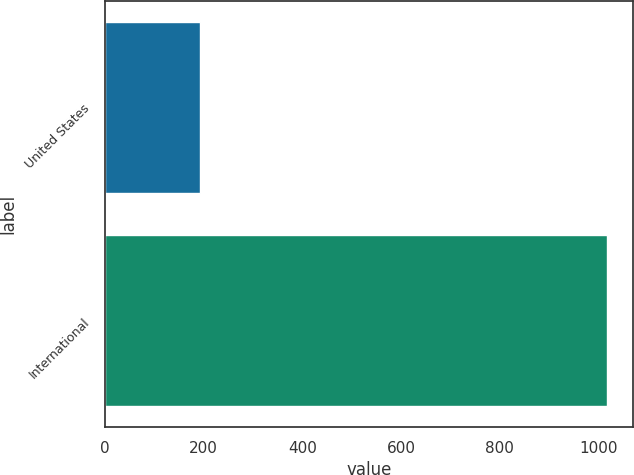<chart> <loc_0><loc_0><loc_500><loc_500><bar_chart><fcel>United States<fcel>International<nl><fcel>193<fcel>1019<nl></chart> 